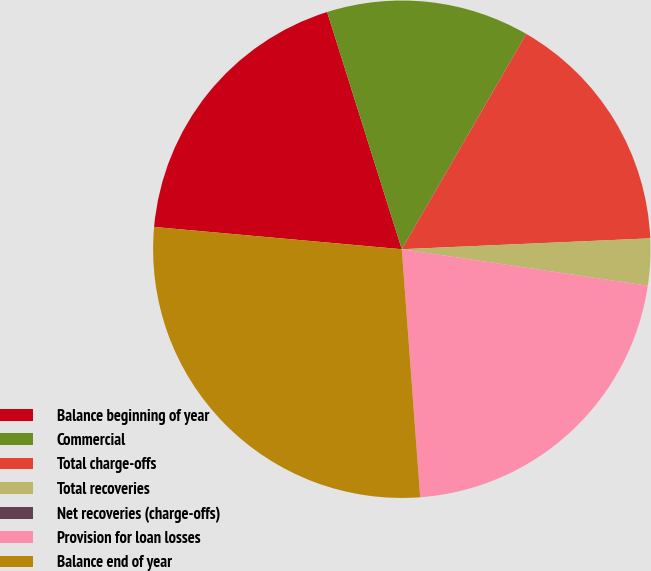Convert chart to OTSL. <chart><loc_0><loc_0><loc_500><loc_500><pie_chart><fcel>Balance beginning of year<fcel>Commercial<fcel>Total charge-offs<fcel>Total recoveries<fcel>Net recoveries (charge-offs)<fcel>Provision for loan losses<fcel>Balance end of year<nl><fcel>18.72%<fcel>13.2%<fcel>15.96%<fcel>3.04%<fcel>0.0%<fcel>21.48%<fcel>27.61%<nl></chart> 